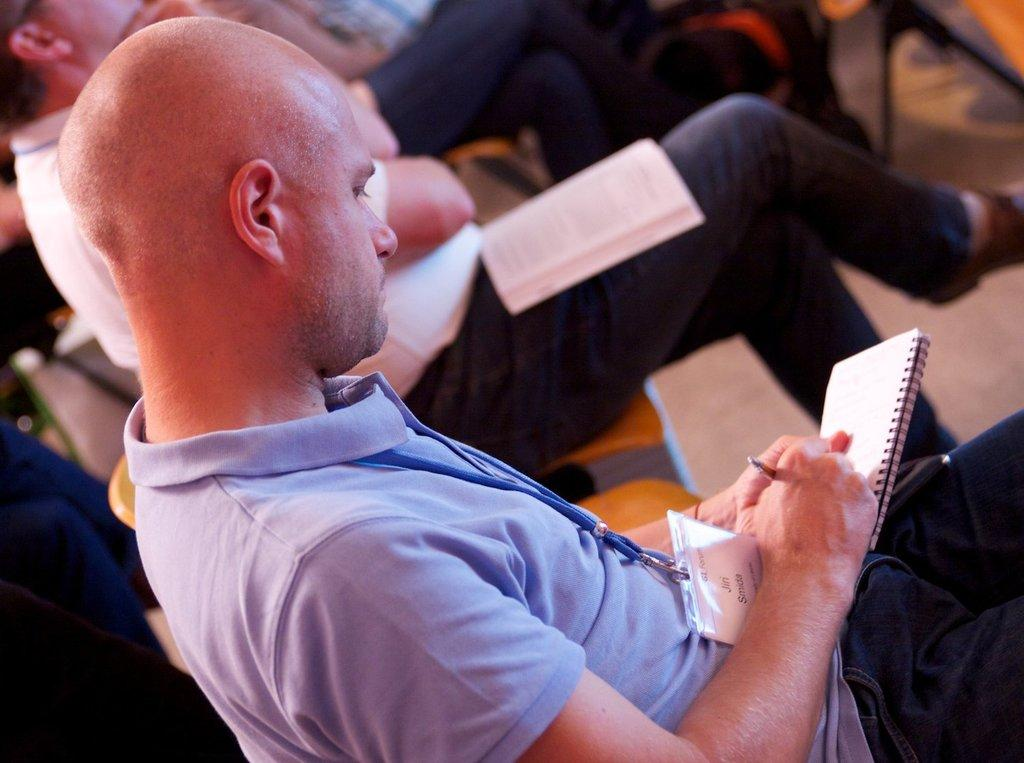What is the person in the image doing? The person is sitting and writing in a book. What is the person wearing? The person is wearing a blue shirt and black pants. Are there any other people in the image? Yes, there are other persons sitting in the background of the image. What type of stone is being pushed by the person in the image? There is no stone or pushing action depicted in the image; the person is sitting and writing in a book. 